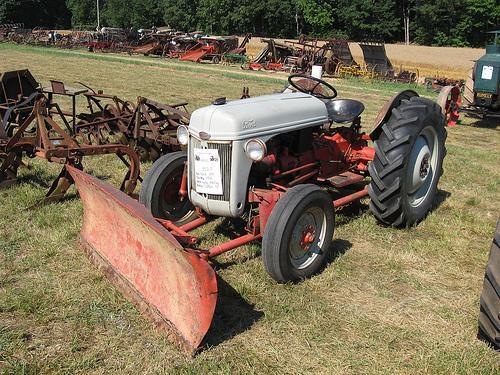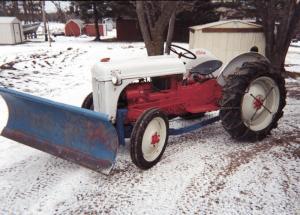The first image is the image on the left, the second image is the image on the right. Considering the images on both sides, is "there are two trees in the image on the right." valid? Answer yes or no. Yes. The first image is the image on the left, the second image is the image on the right. Given the left and right images, does the statement "Right image shows a tractor with plow on a snow-covered ground." hold true? Answer yes or no. Yes. 